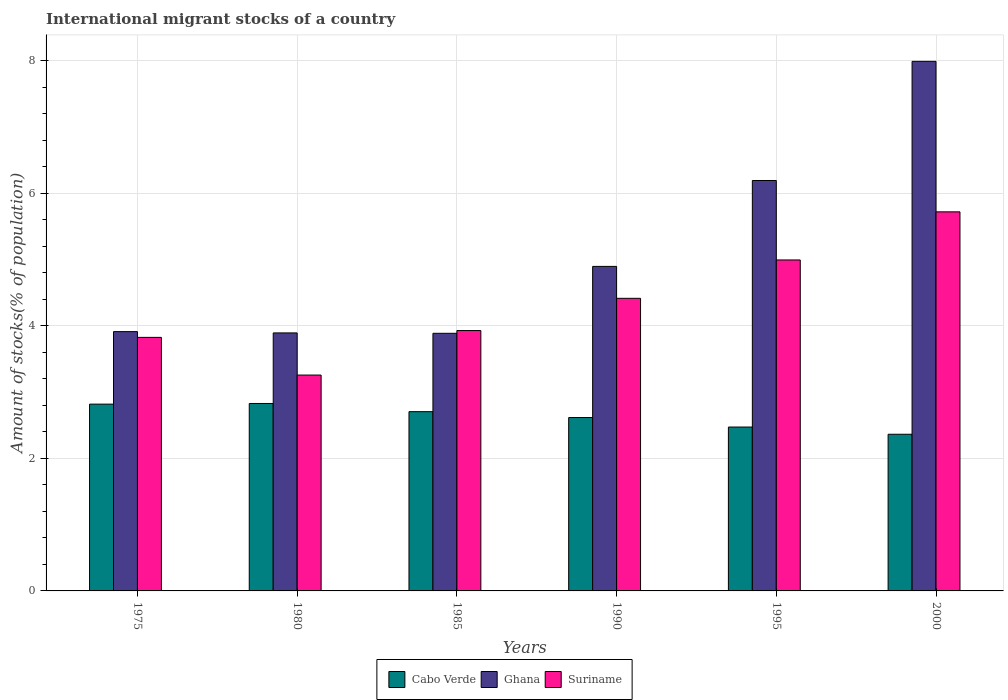How many different coloured bars are there?
Make the answer very short. 3. How many groups of bars are there?
Provide a short and direct response. 6. Are the number of bars per tick equal to the number of legend labels?
Your answer should be compact. Yes. How many bars are there on the 5th tick from the right?
Ensure brevity in your answer.  3. What is the label of the 5th group of bars from the left?
Make the answer very short. 1995. What is the amount of stocks in in Suriname in 1985?
Keep it short and to the point. 3.93. Across all years, what is the maximum amount of stocks in in Suriname?
Provide a short and direct response. 5.72. Across all years, what is the minimum amount of stocks in in Suriname?
Your response must be concise. 3.26. What is the total amount of stocks in in Cabo Verde in the graph?
Ensure brevity in your answer.  15.81. What is the difference between the amount of stocks in in Ghana in 1990 and that in 1995?
Give a very brief answer. -1.3. What is the difference between the amount of stocks in in Ghana in 1975 and the amount of stocks in in Suriname in 1995?
Provide a short and direct response. -1.08. What is the average amount of stocks in in Cabo Verde per year?
Ensure brevity in your answer.  2.63. In the year 2000, what is the difference between the amount of stocks in in Ghana and amount of stocks in in Cabo Verde?
Your answer should be compact. 5.63. In how many years, is the amount of stocks in in Suriname greater than 2 %?
Your answer should be compact. 6. What is the ratio of the amount of stocks in in Suriname in 1980 to that in 1995?
Your answer should be very brief. 0.65. What is the difference between the highest and the second highest amount of stocks in in Suriname?
Your response must be concise. 0.73. What is the difference between the highest and the lowest amount of stocks in in Ghana?
Keep it short and to the point. 4.1. In how many years, is the amount of stocks in in Suriname greater than the average amount of stocks in in Suriname taken over all years?
Your answer should be compact. 3. What does the 3rd bar from the left in 1985 represents?
Make the answer very short. Suriname. How many years are there in the graph?
Provide a short and direct response. 6. What is the difference between two consecutive major ticks on the Y-axis?
Offer a very short reply. 2. Does the graph contain grids?
Make the answer very short. Yes. What is the title of the graph?
Provide a short and direct response. International migrant stocks of a country. Does "Cuba" appear as one of the legend labels in the graph?
Your answer should be compact. No. What is the label or title of the Y-axis?
Give a very brief answer. Amount of stocks(% of population). What is the Amount of stocks(% of population) in Cabo Verde in 1975?
Keep it short and to the point. 2.82. What is the Amount of stocks(% of population) of Ghana in 1975?
Offer a terse response. 3.91. What is the Amount of stocks(% of population) of Suriname in 1975?
Offer a terse response. 3.83. What is the Amount of stocks(% of population) of Cabo Verde in 1980?
Give a very brief answer. 2.83. What is the Amount of stocks(% of population) of Ghana in 1980?
Your response must be concise. 3.89. What is the Amount of stocks(% of population) of Suriname in 1980?
Provide a short and direct response. 3.26. What is the Amount of stocks(% of population) in Cabo Verde in 1985?
Your answer should be very brief. 2.71. What is the Amount of stocks(% of population) in Ghana in 1985?
Keep it short and to the point. 3.89. What is the Amount of stocks(% of population) of Suriname in 1985?
Your answer should be compact. 3.93. What is the Amount of stocks(% of population) in Cabo Verde in 1990?
Provide a short and direct response. 2.62. What is the Amount of stocks(% of population) of Ghana in 1990?
Give a very brief answer. 4.9. What is the Amount of stocks(% of population) of Suriname in 1990?
Offer a very short reply. 4.42. What is the Amount of stocks(% of population) in Cabo Verde in 1995?
Provide a succinct answer. 2.47. What is the Amount of stocks(% of population) in Ghana in 1995?
Keep it short and to the point. 6.2. What is the Amount of stocks(% of population) of Suriname in 1995?
Offer a terse response. 5. What is the Amount of stocks(% of population) of Cabo Verde in 2000?
Your response must be concise. 2.36. What is the Amount of stocks(% of population) in Ghana in 2000?
Your answer should be compact. 7.99. What is the Amount of stocks(% of population) of Suriname in 2000?
Your answer should be compact. 5.72. Across all years, what is the maximum Amount of stocks(% of population) of Cabo Verde?
Offer a very short reply. 2.83. Across all years, what is the maximum Amount of stocks(% of population) of Ghana?
Provide a short and direct response. 7.99. Across all years, what is the maximum Amount of stocks(% of population) of Suriname?
Offer a terse response. 5.72. Across all years, what is the minimum Amount of stocks(% of population) of Cabo Verde?
Offer a terse response. 2.36. Across all years, what is the minimum Amount of stocks(% of population) of Ghana?
Give a very brief answer. 3.89. Across all years, what is the minimum Amount of stocks(% of population) of Suriname?
Ensure brevity in your answer.  3.26. What is the total Amount of stocks(% of population) in Cabo Verde in the graph?
Ensure brevity in your answer.  15.81. What is the total Amount of stocks(% of population) of Ghana in the graph?
Give a very brief answer. 30.78. What is the total Amount of stocks(% of population) in Suriname in the graph?
Offer a terse response. 26.15. What is the difference between the Amount of stocks(% of population) in Cabo Verde in 1975 and that in 1980?
Your answer should be very brief. -0.01. What is the difference between the Amount of stocks(% of population) of Ghana in 1975 and that in 1980?
Keep it short and to the point. 0.02. What is the difference between the Amount of stocks(% of population) of Suriname in 1975 and that in 1980?
Your response must be concise. 0.57. What is the difference between the Amount of stocks(% of population) in Cabo Verde in 1975 and that in 1985?
Your answer should be compact. 0.11. What is the difference between the Amount of stocks(% of population) in Ghana in 1975 and that in 1985?
Provide a short and direct response. 0.03. What is the difference between the Amount of stocks(% of population) in Suriname in 1975 and that in 1985?
Make the answer very short. -0.1. What is the difference between the Amount of stocks(% of population) in Cabo Verde in 1975 and that in 1990?
Offer a very short reply. 0.2. What is the difference between the Amount of stocks(% of population) in Ghana in 1975 and that in 1990?
Make the answer very short. -0.98. What is the difference between the Amount of stocks(% of population) in Suriname in 1975 and that in 1990?
Your response must be concise. -0.59. What is the difference between the Amount of stocks(% of population) of Cabo Verde in 1975 and that in 1995?
Your answer should be compact. 0.35. What is the difference between the Amount of stocks(% of population) of Ghana in 1975 and that in 1995?
Make the answer very short. -2.28. What is the difference between the Amount of stocks(% of population) of Suriname in 1975 and that in 1995?
Offer a terse response. -1.17. What is the difference between the Amount of stocks(% of population) in Cabo Verde in 1975 and that in 2000?
Keep it short and to the point. 0.45. What is the difference between the Amount of stocks(% of population) in Ghana in 1975 and that in 2000?
Your answer should be compact. -4.08. What is the difference between the Amount of stocks(% of population) in Suriname in 1975 and that in 2000?
Provide a succinct answer. -1.89. What is the difference between the Amount of stocks(% of population) in Cabo Verde in 1980 and that in 1985?
Provide a succinct answer. 0.12. What is the difference between the Amount of stocks(% of population) of Ghana in 1980 and that in 1985?
Offer a very short reply. 0.01. What is the difference between the Amount of stocks(% of population) of Suriname in 1980 and that in 1985?
Ensure brevity in your answer.  -0.67. What is the difference between the Amount of stocks(% of population) of Cabo Verde in 1980 and that in 1990?
Make the answer very short. 0.21. What is the difference between the Amount of stocks(% of population) of Ghana in 1980 and that in 1990?
Your response must be concise. -1. What is the difference between the Amount of stocks(% of population) in Suriname in 1980 and that in 1990?
Your answer should be very brief. -1.16. What is the difference between the Amount of stocks(% of population) in Cabo Verde in 1980 and that in 1995?
Provide a succinct answer. 0.36. What is the difference between the Amount of stocks(% of population) of Ghana in 1980 and that in 1995?
Provide a succinct answer. -2.3. What is the difference between the Amount of stocks(% of population) of Suriname in 1980 and that in 1995?
Make the answer very short. -1.74. What is the difference between the Amount of stocks(% of population) of Cabo Verde in 1980 and that in 2000?
Your response must be concise. 0.46. What is the difference between the Amount of stocks(% of population) of Ghana in 1980 and that in 2000?
Provide a succinct answer. -4.1. What is the difference between the Amount of stocks(% of population) of Suriname in 1980 and that in 2000?
Provide a short and direct response. -2.46. What is the difference between the Amount of stocks(% of population) in Cabo Verde in 1985 and that in 1990?
Offer a terse response. 0.09. What is the difference between the Amount of stocks(% of population) in Ghana in 1985 and that in 1990?
Give a very brief answer. -1.01. What is the difference between the Amount of stocks(% of population) of Suriname in 1985 and that in 1990?
Your response must be concise. -0.49. What is the difference between the Amount of stocks(% of population) in Cabo Verde in 1985 and that in 1995?
Your answer should be compact. 0.23. What is the difference between the Amount of stocks(% of population) of Ghana in 1985 and that in 1995?
Your answer should be compact. -2.31. What is the difference between the Amount of stocks(% of population) of Suriname in 1985 and that in 1995?
Offer a terse response. -1.07. What is the difference between the Amount of stocks(% of population) of Cabo Verde in 1985 and that in 2000?
Your answer should be compact. 0.34. What is the difference between the Amount of stocks(% of population) in Ghana in 1985 and that in 2000?
Give a very brief answer. -4.1. What is the difference between the Amount of stocks(% of population) in Suriname in 1985 and that in 2000?
Ensure brevity in your answer.  -1.79. What is the difference between the Amount of stocks(% of population) of Cabo Verde in 1990 and that in 1995?
Your answer should be compact. 0.14. What is the difference between the Amount of stocks(% of population) of Ghana in 1990 and that in 1995?
Make the answer very short. -1.3. What is the difference between the Amount of stocks(% of population) of Suriname in 1990 and that in 1995?
Make the answer very short. -0.58. What is the difference between the Amount of stocks(% of population) in Cabo Verde in 1990 and that in 2000?
Provide a succinct answer. 0.25. What is the difference between the Amount of stocks(% of population) in Ghana in 1990 and that in 2000?
Offer a very short reply. -3.09. What is the difference between the Amount of stocks(% of population) in Suriname in 1990 and that in 2000?
Provide a short and direct response. -1.31. What is the difference between the Amount of stocks(% of population) in Cabo Verde in 1995 and that in 2000?
Keep it short and to the point. 0.11. What is the difference between the Amount of stocks(% of population) in Ghana in 1995 and that in 2000?
Make the answer very short. -1.8. What is the difference between the Amount of stocks(% of population) in Suriname in 1995 and that in 2000?
Your response must be concise. -0.73. What is the difference between the Amount of stocks(% of population) in Cabo Verde in 1975 and the Amount of stocks(% of population) in Ghana in 1980?
Offer a terse response. -1.07. What is the difference between the Amount of stocks(% of population) in Cabo Verde in 1975 and the Amount of stocks(% of population) in Suriname in 1980?
Make the answer very short. -0.44. What is the difference between the Amount of stocks(% of population) of Ghana in 1975 and the Amount of stocks(% of population) of Suriname in 1980?
Provide a succinct answer. 0.66. What is the difference between the Amount of stocks(% of population) of Cabo Verde in 1975 and the Amount of stocks(% of population) of Ghana in 1985?
Provide a succinct answer. -1.07. What is the difference between the Amount of stocks(% of population) in Cabo Verde in 1975 and the Amount of stocks(% of population) in Suriname in 1985?
Provide a succinct answer. -1.11. What is the difference between the Amount of stocks(% of population) of Ghana in 1975 and the Amount of stocks(% of population) of Suriname in 1985?
Offer a very short reply. -0.02. What is the difference between the Amount of stocks(% of population) of Cabo Verde in 1975 and the Amount of stocks(% of population) of Ghana in 1990?
Ensure brevity in your answer.  -2.08. What is the difference between the Amount of stocks(% of population) in Cabo Verde in 1975 and the Amount of stocks(% of population) in Suriname in 1990?
Provide a short and direct response. -1.6. What is the difference between the Amount of stocks(% of population) in Ghana in 1975 and the Amount of stocks(% of population) in Suriname in 1990?
Ensure brevity in your answer.  -0.5. What is the difference between the Amount of stocks(% of population) of Cabo Verde in 1975 and the Amount of stocks(% of population) of Ghana in 1995?
Provide a succinct answer. -3.38. What is the difference between the Amount of stocks(% of population) in Cabo Verde in 1975 and the Amount of stocks(% of population) in Suriname in 1995?
Offer a very short reply. -2.18. What is the difference between the Amount of stocks(% of population) in Ghana in 1975 and the Amount of stocks(% of population) in Suriname in 1995?
Make the answer very short. -1.08. What is the difference between the Amount of stocks(% of population) in Cabo Verde in 1975 and the Amount of stocks(% of population) in Ghana in 2000?
Your response must be concise. -5.17. What is the difference between the Amount of stocks(% of population) of Cabo Verde in 1975 and the Amount of stocks(% of population) of Suriname in 2000?
Keep it short and to the point. -2.9. What is the difference between the Amount of stocks(% of population) of Ghana in 1975 and the Amount of stocks(% of population) of Suriname in 2000?
Provide a succinct answer. -1.81. What is the difference between the Amount of stocks(% of population) of Cabo Verde in 1980 and the Amount of stocks(% of population) of Ghana in 1985?
Offer a terse response. -1.06. What is the difference between the Amount of stocks(% of population) in Cabo Verde in 1980 and the Amount of stocks(% of population) in Suriname in 1985?
Your response must be concise. -1.1. What is the difference between the Amount of stocks(% of population) of Ghana in 1980 and the Amount of stocks(% of population) of Suriname in 1985?
Provide a succinct answer. -0.04. What is the difference between the Amount of stocks(% of population) of Cabo Verde in 1980 and the Amount of stocks(% of population) of Ghana in 1990?
Offer a terse response. -2.07. What is the difference between the Amount of stocks(% of population) of Cabo Verde in 1980 and the Amount of stocks(% of population) of Suriname in 1990?
Your answer should be compact. -1.59. What is the difference between the Amount of stocks(% of population) in Ghana in 1980 and the Amount of stocks(% of population) in Suriname in 1990?
Your answer should be compact. -0.52. What is the difference between the Amount of stocks(% of population) in Cabo Verde in 1980 and the Amount of stocks(% of population) in Ghana in 1995?
Your answer should be very brief. -3.37. What is the difference between the Amount of stocks(% of population) in Cabo Verde in 1980 and the Amount of stocks(% of population) in Suriname in 1995?
Provide a succinct answer. -2.17. What is the difference between the Amount of stocks(% of population) in Ghana in 1980 and the Amount of stocks(% of population) in Suriname in 1995?
Your response must be concise. -1.1. What is the difference between the Amount of stocks(% of population) in Cabo Verde in 1980 and the Amount of stocks(% of population) in Ghana in 2000?
Give a very brief answer. -5.16. What is the difference between the Amount of stocks(% of population) of Cabo Verde in 1980 and the Amount of stocks(% of population) of Suriname in 2000?
Your answer should be very brief. -2.89. What is the difference between the Amount of stocks(% of population) of Ghana in 1980 and the Amount of stocks(% of population) of Suriname in 2000?
Your answer should be very brief. -1.83. What is the difference between the Amount of stocks(% of population) of Cabo Verde in 1985 and the Amount of stocks(% of population) of Ghana in 1990?
Give a very brief answer. -2.19. What is the difference between the Amount of stocks(% of population) in Cabo Verde in 1985 and the Amount of stocks(% of population) in Suriname in 1990?
Offer a terse response. -1.71. What is the difference between the Amount of stocks(% of population) of Ghana in 1985 and the Amount of stocks(% of population) of Suriname in 1990?
Your response must be concise. -0.53. What is the difference between the Amount of stocks(% of population) in Cabo Verde in 1985 and the Amount of stocks(% of population) in Ghana in 1995?
Keep it short and to the point. -3.49. What is the difference between the Amount of stocks(% of population) in Cabo Verde in 1985 and the Amount of stocks(% of population) in Suriname in 1995?
Your answer should be very brief. -2.29. What is the difference between the Amount of stocks(% of population) in Ghana in 1985 and the Amount of stocks(% of population) in Suriname in 1995?
Provide a short and direct response. -1.11. What is the difference between the Amount of stocks(% of population) of Cabo Verde in 1985 and the Amount of stocks(% of population) of Ghana in 2000?
Offer a terse response. -5.29. What is the difference between the Amount of stocks(% of population) in Cabo Verde in 1985 and the Amount of stocks(% of population) in Suriname in 2000?
Offer a terse response. -3.02. What is the difference between the Amount of stocks(% of population) in Ghana in 1985 and the Amount of stocks(% of population) in Suriname in 2000?
Your answer should be compact. -1.83. What is the difference between the Amount of stocks(% of population) of Cabo Verde in 1990 and the Amount of stocks(% of population) of Ghana in 1995?
Offer a very short reply. -3.58. What is the difference between the Amount of stocks(% of population) of Cabo Verde in 1990 and the Amount of stocks(% of population) of Suriname in 1995?
Keep it short and to the point. -2.38. What is the difference between the Amount of stocks(% of population) in Ghana in 1990 and the Amount of stocks(% of population) in Suriname in 1995?
Keep it short and to the point. -0.1. What is the difference between the Amount of stocks(% of population) in Cabo Verde in 1990 and the Amount of stocks(% of population) in Ghana in 2000?
Give a very brief answer. -5.38. What is the difference between the Amount of stocks(% of population) in Cabo Verde in 1990 and the Amount of stocks(% of population) in Suriname in 2000?
Provide a short and direct response. -3.1. What is the difference between the Amount of stocks(% of population) in Ghana in 1990 and the Amount of stocks(% of population) in Suriname in 2000?
Give a very brief answer. -0.82. What is the difference between the Amount of stocks(% of population) in Cabo Verde in 1995 and the Amount of stocks(% of population) in Ghana in 2000?
Offer a terse response. -5.52. What is the difference between the Amount of stocks(% of population) in Cabo Verde in 1995 and the Amount of stocks(% of population) in Suriname in 2000?
Keep it short and to the point. -3.25. What is the difference between the Amount of stocks(% of population) in Ghana in 1995 and the Amount of stocks(% of population) in Suriname in 2000?
Give a very brief answer. 0.47. What is the average Amount of stocks(% of population) of Cabo Verde per year?
Make the answer very short. 2.63. What is the average Amount of stocks(% of population) of Ghana per year?
Your response must be concise. 5.13. What is the average Amount of stocks(% of population) in Suriname per year?
Offer a very short reply. 4.36. In the year 1975, what is the difference between the Amount of stocks(% of population) in Cabo Verde and Amount of stocks(% of population) in Ghana?
Your answer should be very brief. -1.09. In the year 1975, what is the difference between the Amount of stocks(% of population) in Cabo Verde and Amount of stocks(% of population) in Suriname?
Keep it short and to the point. -1.01. In the year 1975, what is the difference between the Amount of stocks(% of population) of Ghana and Amount of stocks(% of population) of Suriname?
Give a very brief answer. 0.09. In the year 1980, what is the difference between the Amount of stocks(% of population) of Cabo Verde and Amount of stocks(% of population) of Ghana?
Your response must be concise. -1.07. In the year 1980, what is the difference between the Amount of stocks(% of population) in Cabo Verde and Amount of stocks(% of population) in Suriname?
Provide a short and direct response. -0.43. In the year 1980, what is the difference between the Amount of stocks(% of population) of Ghana and Amount of stocks(% of population) of Suriname?
Offer a terse response. 0.64. In the year 1985, what is the difference between the Amount of stocks(% of population) in Cabo Verde and Amount of stocks(% of population) in Ghana?
Offer a terse response. -1.18. In the year 1985, what is the difference between the Amount of stocks(% of population) in Cabo Verde and Amount of stocks(% of population) in Suriname?
Provide a succinct answer. -1.22. In the year 1985, what is the difference between the Amount of stocks(% of population) of Ghana and Amount of stocks(% of population) of Suriname?
Your answer should be very brief. -0.04. In the year 1990, what is the difference between the Amount of stocks(% of population) of Cabo Verde and Amount of stocks(% of population) of Ghana?
Provide a short and direct response. -2.28. In the year 1990, what is the difference between the Amount of stocks(% of population) in Cabo Verde and Amount of stocks(% of population) in Suriname?
Your answer should be compact. -1.8. In the year 1990, what is the difference between the Amount of stocks(% of population) of Ghana and Amount of stocks(% of population) of Suriname?
Keep it short and to the point. 0.48. In the year 1995, what is the difference between the Amount of stocks(% of population) of Cabo Verde and Amount of stocks(% of population) of Ghana?
Provide a short and direct response. -3.72. In the year 1995, what is the difference between the Amount of stocks(% of population) of Cabo Verde and Amount of stocks(% of population) of Suriname?
Your response must be concise. -2.52. In the year 1995, what is the difference between the Amount of stocks(% of population) in Ghana and Amount of stocks(% of population) in Suriname?
Provide a short and direct response. 1.2. In the year 2000, what is the difference between the Amount of stocks(% of population) of Cabo Verde and Amount of stocks(% of population) of Ghana?
Your answer should be compact. -5.63. In the year 2000, what is the difference between the Amount of stocks(% of population) in Cabo Verde and Amount of stocks(% of population) in Suriname?
Ensure brevity in your answer.  -3.36. In the year 2000, what is the difference between the Amount of stocks(% of population) in Ghana and Amount of stocks(% of population) in Suriname?
Offer a very short reply. 2.27. What is the ratio of the Amount of stocks(% of population) of Suriname in 1975 to that in 1980?
Keep it short and to the point. 1.17. What is the ratio of the Amount of stocks(% of population) in Cabo Verde in 1975 to that in 1985?
Give a very brief answer. 1.04. What is the ratio of the Amount of stocks(% of population) in Ghana in 1975 to that in 1985?
Offer a terse response. 1.01. What is the ratio of the Amount of stocks(% of population) in Suriname in 1975 to that in 1985?
Offer a very short reply. 0.97. What is the ratio of the Amount of stocks(% of population) in Cabo Verde in 1975 to that in 1990?
Offer a very short reply. 1.08. What is the ratio of the Amount of stocks(% of population) of Ghana in 1975 to that in 1990?
Provide a succinct answer. 0.8. What is the ratio of the Amount of stocks(% of population) in Suriname in 1975 to that in 1990?
Your response must be concise. 0.87. What is the ratio of the Amount of stocks(% of population) in Cabo Verde in 1975 to that in 1995?
Offer a very short reply. 1.14. What is the ratio of the Amount of stocks(% of population) in Ghana in 1975 to that in 1995?
Provide a short and direct response. 0.63. What is the ratio of the Amount of stocks(% of population) of Suriname in 1975 to that in 1995?
Give a very brief answer. 0.77. What is the ratio of the Amount of stocks(% of population) of Cabo Verde in 1975 to that in 2000?
Make the answer very short. 1.19. What is the ratio of the Amount of stocks(% of population) of Ghana in 1975 to that in 2000?
Ensure brevity in your answer.  0.49. What is the ratio of the Amount of stocks(% of population) of Suriname in 1975 to that in 2000?
Ensure brevity in your answer.  0.67. What is the ratio of the Amount of stocks(% of population) of Cabo Verde in 1980 to that in 1985?
Provide a succinct answer. 1.05. What is the ratio of the Amount of stocks(% of population) of Ghana in 1980 to that in 1985?
Keep it short and to the point. 1. What is the ratio of the Amount of stocks(% of population) in Suriname in 1980 to that in 1985?
Make the answer very short. 0.83. What is the ratio of the Amount of stocks(% of population) in Cabo Verde in 1980 to that in 1990?
Keep it short and to the point. 1.08. What is the ratio of the Amount of stocks(% of population) in Ghana in 1980 to that in 1990?
Provide a succinct answer. 0.8. What is the ratio of the Amount of stocks(% of population) in Suriname in 1980 to that in 1990?
Offer a very short reply. 0.74. What is the ratio of the Amount of stocks(% of population) in Cabo Verde in 1980 to that in 1995?
Make the answer very short. 1.14. What is the ratio of the Amount of stocks(% of population) in Ghana in 1980 to that in 1995?
Your answer should be compact. 0.63. What is the ratio of the Amount of stocks(% of population) in Suriname in 1980 to that in 1995?
Make the answer very short. 0.65. What is the ratio of the Amount of stocks(% of population) of Cabo Verde in 1980 to that in 2000?
Your answer should be very brief. 1.2. What is the ratio of the Amount of stocks(% of population) in Ghana in 1980 to that in 2000?
Your response must be concise. 0.49. What is the ratio of the Amount of stocks(% of population) of Suriname in 1980 to that in 2000?
Your answer should be very brief. 0.57. What is the ratio of the Amount of stocks(% of population) of Cabo Verde in 1985 to that in 1990?
Offer a terse response. 1.03. What is the ratio of the Amount of stocks(% of population) in Ghana in 1985 to that in 1990?
Ensure brevity in your answer.  0.79. What is the ratio of the Amount of stocks(% of population) of Suriname in 1985 to that in 1990?
Make the answer very short. 0.89. What is the ratio of the Amount of stocks(% of population) of Cabo Verde in 1985 to that in 1995?
Ensure brevity in your answer.  1.09. What is the ratio of the Amount of stocks(% of population) of Ghana in 1985 to that in 1995?
Keep it short and to the point. 0.63. What is the ratio of the Amount of stocks(% of population) in Suriname in 1985 to that in 1995?
Your answer should be compact. 0.79. What is the ratio of the Amount of stocks(% of population) in Cabo Verde in 1985 to that in 2000?
Provide a short and direct response. 1.14. What is the ratio of the Amount of stocks(% of population) in Ghana in 1985 to that in 2000?
Your answer should be compact. 0.49. What is the ratio of the Amount of stocks(% of population) in Suriname in 1985 to that in 2000?
Keep it short and to the point. 0.69. What is the ratio of the Amount of stocks(% of population) in Cabo Verde in 1990 to that in 1995?
Your response must be concise. 1.06. What is the ratio of the Amount of stocks(% of population) in Ghana in 1990 to that in 1995?
Make the answer very short. 0.79. What is the ratio of the Amount of stocks(% of population) in Suriname in 1990 to that in 1995?
Ensure brevity in your answer.  0.88. What is the ratio of the Amount of stocks(% of population) in Cabo Verde in 1990 to that in 2000?
Provide a short and direct response. 1.11. What is the ratio of the Amount of stocks(% of population) of Ghana in 1990 to that in 2000?
Offer a very short reply. 0.61. What is the ratio of the Amount of stocks(% of population) of Suriname in 1990 to that in 2000?
Your answer should be compact. 0.77. What is the ratio of the Amount of stocks(% of population) in Cabo Verde in 1995 to that in 2000?
Your response must be concise. 1.05. What is the ratio of the Amount of stocks(% of population) in Ghana in 1995 to that in 2000?
Your answer should be very brief. 0.78. What is the ratio of the Amount of stocks(% of population) in Suriname in 1995 to that in 2000?
Provide a succinct answer. 0.87. What is the difference between the highest and the second highest Amount of stocks(% of population) in Cabo Verde?
Provide a short and direct response. 0.01. What is the difference between the highest and the second highest Amount of stocks(% of population) in Ghana?
Keep it short and to the point. 1.8. What is the difference between the highest and the second highest Amount of stocks(% of population) in Suriname?
Ensure brevity in your answer.  0.73. What is the difference between the highest and the lowest Amount of stocks(% of population) in Cabo Verde?
Offer a terse response. 0.46. What is the difference between the highest and the lowest Amount of stocks(% of population) of Ghana?
Ensure brevity in your answer.  4.1. What is the difference between the highest and the lowest Amount of stocks(% of population) of Suriname?
Your response must be concise. 2.46. 